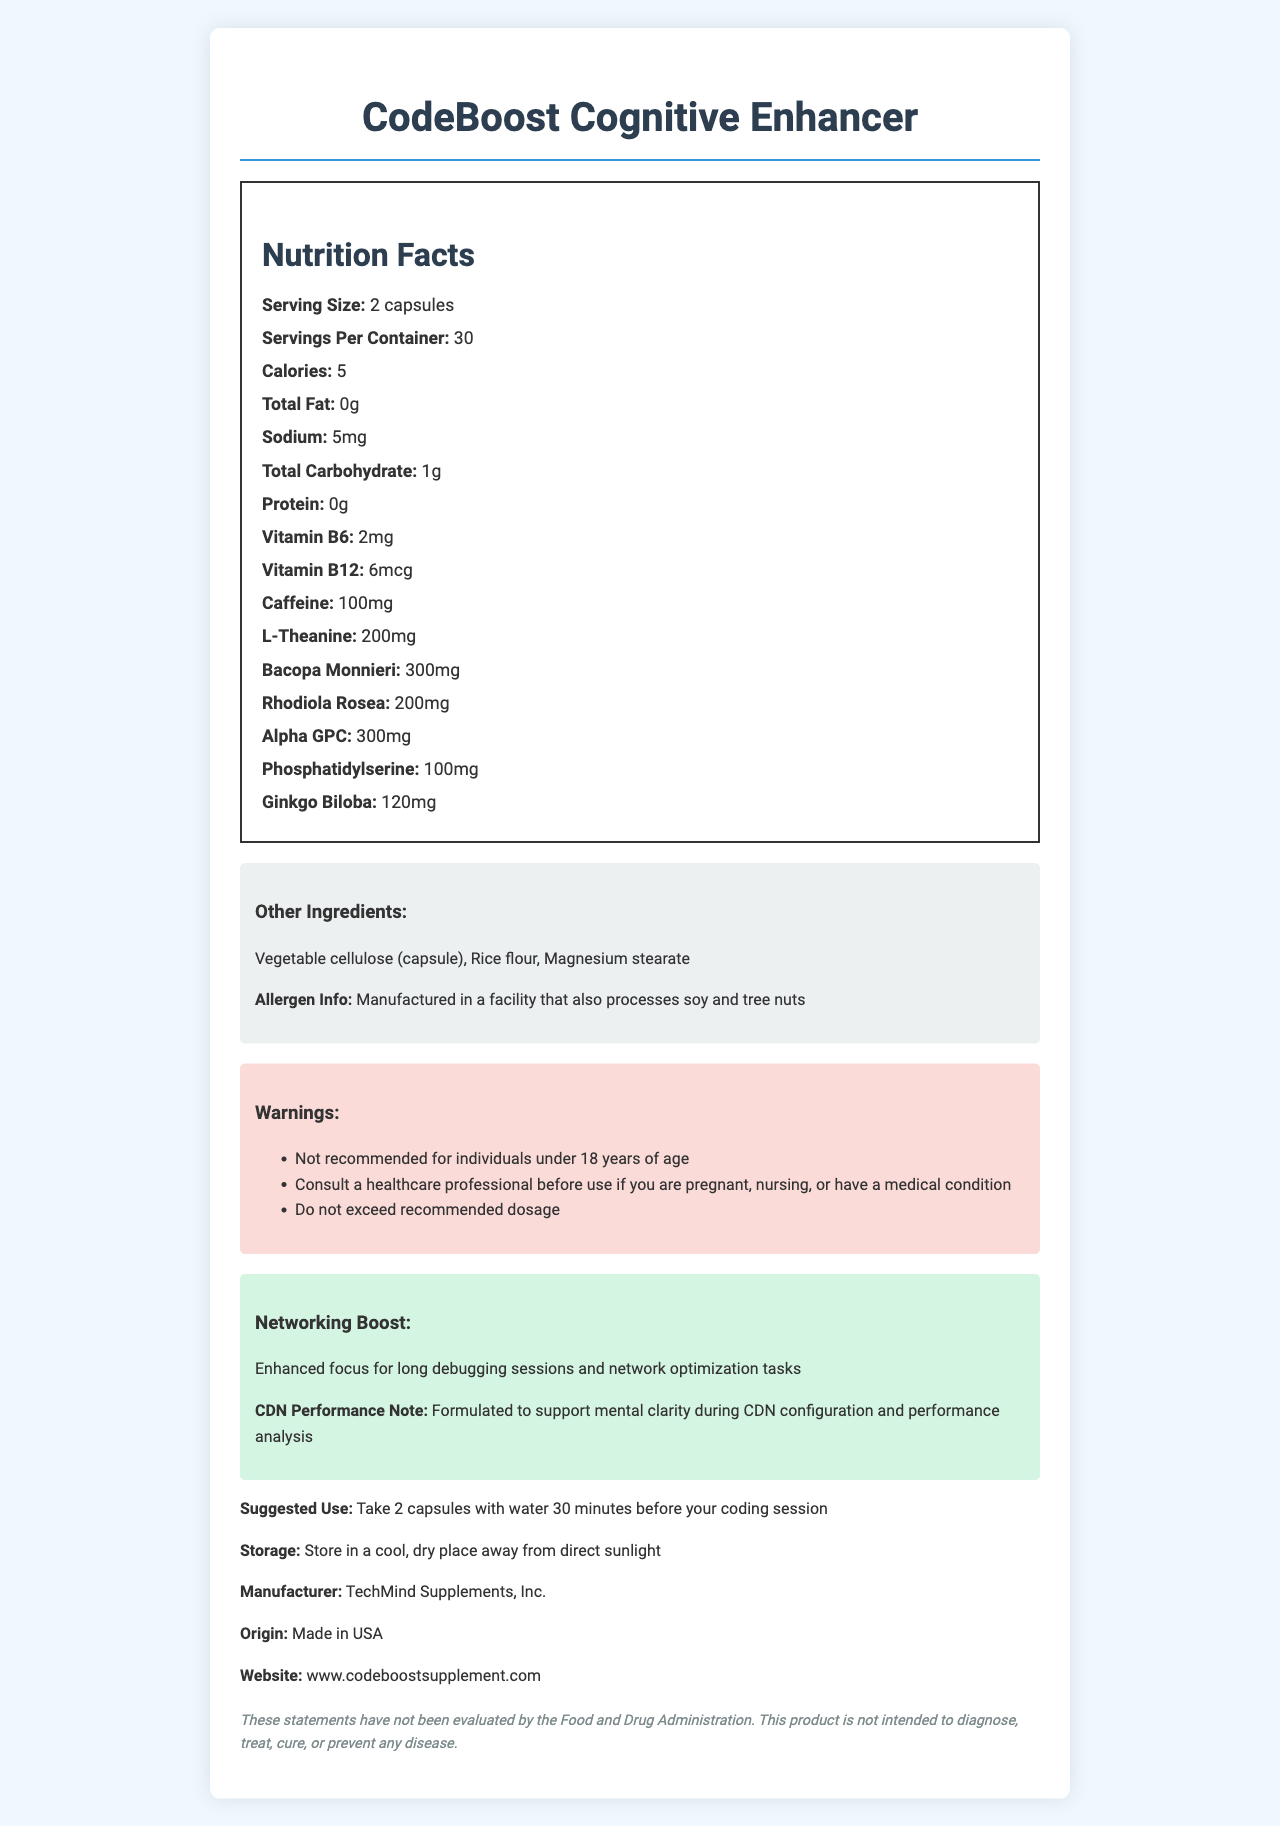what is the serving size for CodeBoost Cognitive Enhancer? The serving size is explicitly mentioned as "2 capsules" in the Nutrition Facts section.
Answer: 2 capsules how much caffeine is in one serving of CodeBoost Cognitive Enhancer? The Nutrition Facts section lists 100mg of caffeine per serving.
Answer: 100mg what is the suggested use for CodeBoost Cognitive Enhancer? The Suggested Use section specifies how and when to take the supplement.
Answer: Take 2 capsules with water 30 minutes before your coding session how many servings are in one container of CodeBoost Cognitive Enhancer? The label indicates there are 30 servings per container.
Answer: 30 what is the total amount of bacopa monnieri in one serving? The amount per serving for bacopa monnieri is listed as 300mg in the Nutrition Facts section.
Answer: 300mg which ingredient is present in the largest quantity per serving? A. Caffeine B. Bacopa Monnieri C. Rhodiola Rosea D. L-Theanine Bacopa Monnieri has the highest content per serving at 300mg, compared to other ingredients.
Answer: B. Bacopa Monnieri which vitamin has a higher amount in one serving? A. Vitamin B6 B. Vitamin B12 Vitamin B6 is present at 2mg per serving, whereas Vitamin B12 is present at 6mcg.
Answer: A. Vitamin B6 is this product appropriate for children under 18? The Warnings section specifically states, "Not recommended for individuals under 18 years of age."
Answer: No does the document provide information on where to store the product? The Storage section instructs to store the product in a cool, dry place away from direct sunlight.
Answer: Yes describe the main idea of the document. The document aims to inform users about the details and benefits of the cognitive supplement, along with its usage guidelines and precautions.
Answer: The document provides detailed information about the CodeBoost Cognitive Enhancer, including its nutrition facts, ingredients, suggested use, storage instructions, and warnings. It emphasizes that the supplement is designed to enhance cognitive function, particularly for long coding sessions and networking tasks. It also contains a disclaimer about FDA evaluation. why is magnesium stearate included in the ingredients? The document lists magnesium stearate as one of the other ingredients, but it does not provide an explanation for its inclusion.
Answer: Cannot be determined 